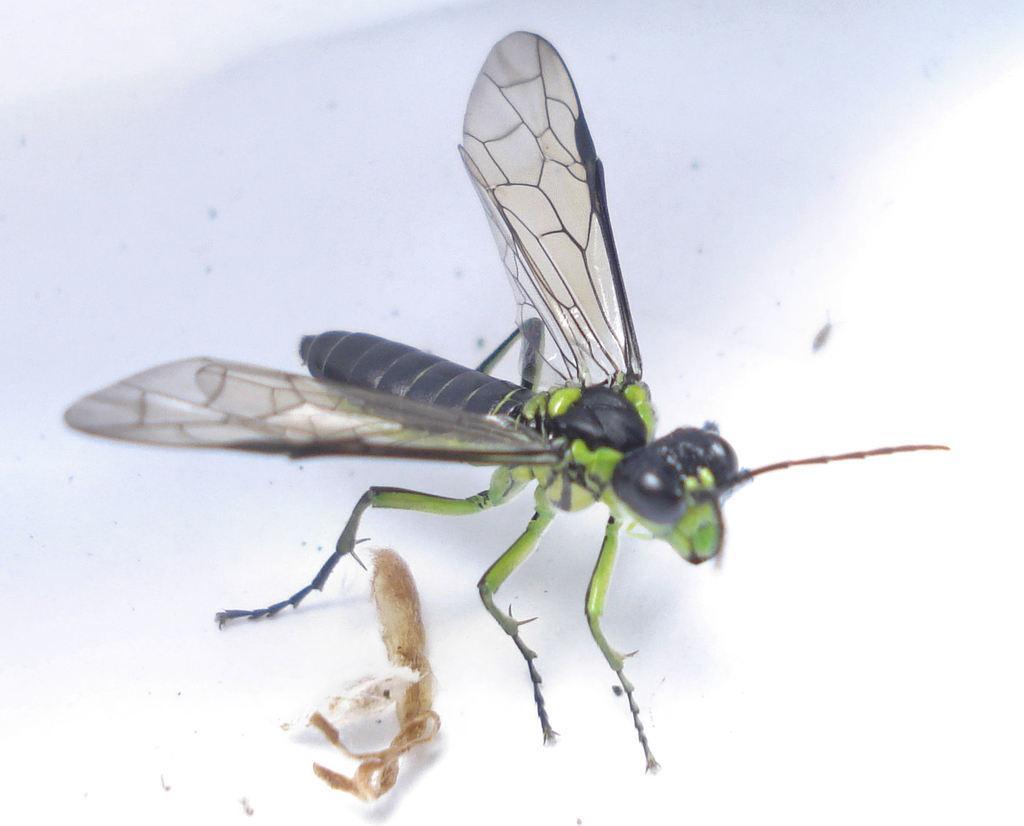Please provide a concise description of this image. In this picture I can see there is a insect and it has wings, body, head and legs. There is a white surface. 